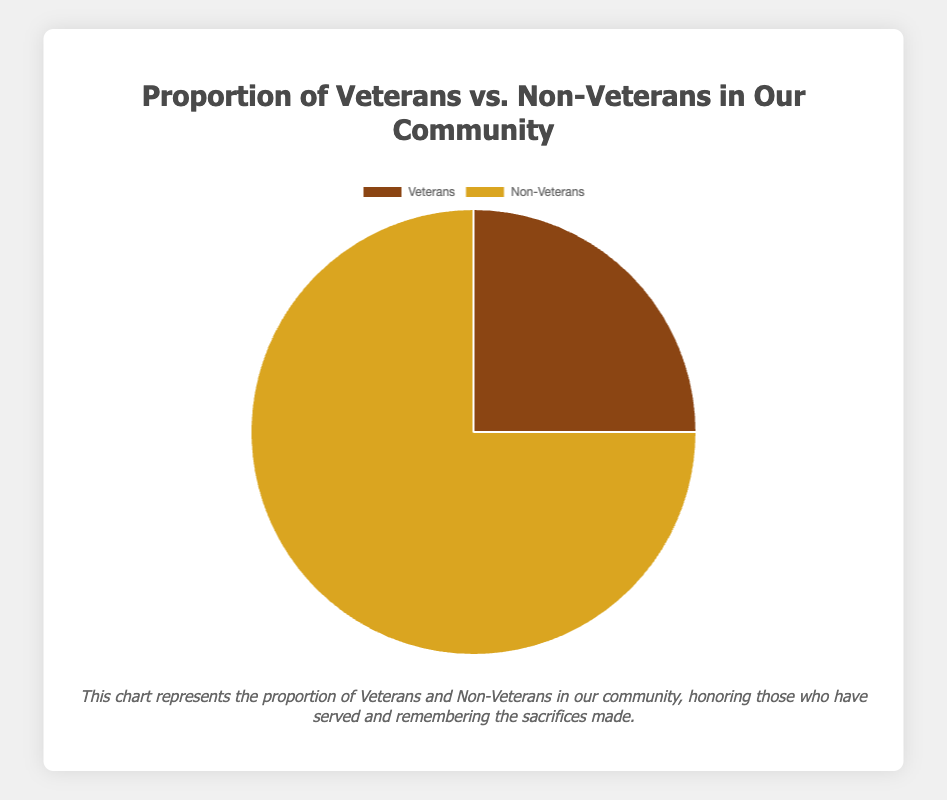What's the percentage of veterans in the community? The chart indicates two segments, and the veterans' segment is labeled with 25%. Therefore, the percentage of veterans in the community is 25%.
Answer: 25% What's the percentage of non-veterans in the community? The chart indicates two segments, and the non-veterans' segment is labeled with 75%. Therefore, the percentage of non-veterans in the community is 75%.
Answer: 75% How much larger is the non-veteran population compared to the veteran population? The non-veteran segment is marked as 75%, and the veteran segment is marked as 25%. The difference between these percentages is 75% - 25% = 50%.
Answer: 50% What fraction of the community does the veteran population constitute? The veteran segment represents 25% of the community. In fractional form, this is 25/100, which simplifies to 1/4.
Answer: 1/4 Which group forms the larger portion of the community? The chart shows that the non-veterans make up 75% of the community, while veterans make up 25%. Therefore, non-veterans form the larger portion.
Answer: Non-veterans How many times larger is the non-veteran population compared to the veteran population? The non-veteran percentage is 75%, and the veteran percentage is 25%. Dividing the non-veteran percentage by the veteran percentage gives 75% / 25% = 3. Thus, the non-veteran population is 3 times larger than the veteran population.
Answer: 3 times What are the colors representing the veterans and non-veterans in the pie chart? The chart uses brown for veterans and gold for non-veterans.
Answer: Brown for veterans, gold for non-veterans If the community has 1000 people, how many of them are veterans? Since 25% of the community are veterans, we calculate 25% of 1000. This is 0.25 * 1000 = 250.
Answer: 250 If this chart represents the whole community, what is the combined percentage of veterans and non-veterans? The chart shows the entire community divided into two groups, veterans and non-veterans. Adding their respective percentages (25% for veterans and 75% for non-veterans) gives us 25% + 75% = 100%.
Answer: 100% 